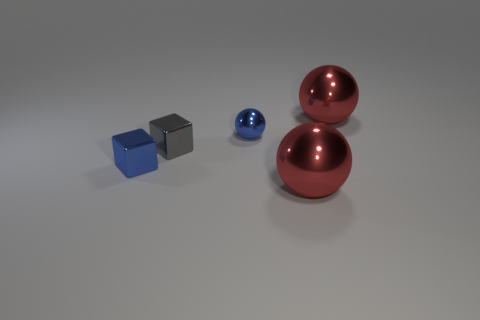Subtract all brown cylinders. How many red spheres are left? 2 Add 1 blue spheres. How many objects exist? 6 Subtract all large spheres. How many spheres are left? 1 Subtract all spheres. How many objects are left? 2 Subtract all yellow spheres. Subtract all red cylinders. How many spheres are left? 3 Subtract all small blue balls. Subtract all small metallic objects. How many objects are left? 1 Add 1 tiny spheres. How many tiny spheres are left? 2 Add 4 metal objects. How many metal objects exist? 9 Subtract 0 gray cylinders. How many objects are left? 5 